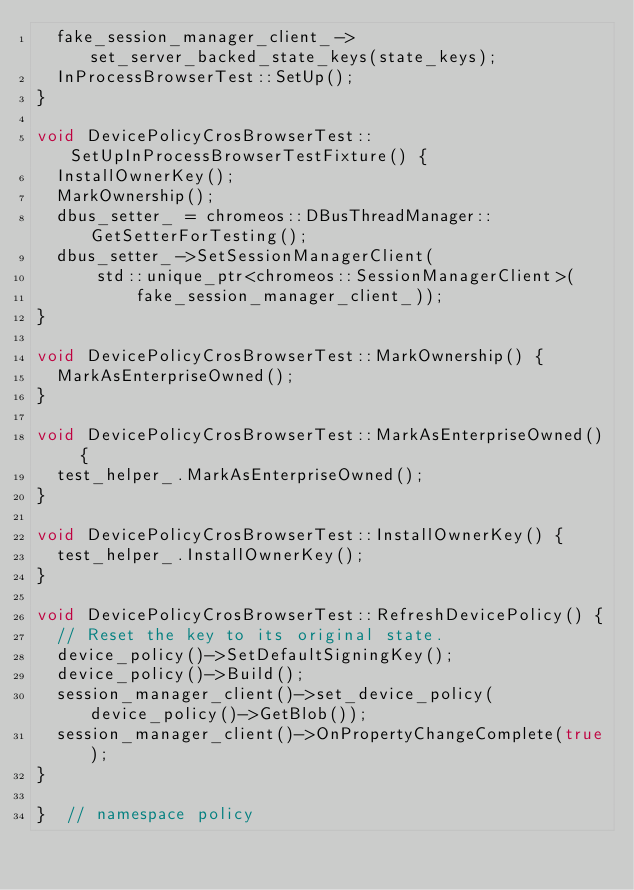<code> <loc_0><loc_0><loc_500><loc_500><_C++_>  fake_session_manager_client_->set_server_backed_state_keys(state_keys);
  InProcessBrowserTest::SetUp();
}

void DevicePolicyCrosBrowserTest::SetUpInProcessBrowserTestFixture() {
  InstallOwnerKey();
  MarkOwnership();
  dbus_setter_ = chromeos::DBusThreadManager::GetSetterForTesting();
  dbus_setter_->SetSessionManagerClient(
      std::unique_ptr<chromeos::SessionManagerClient>(
          fake_session_manager_client_));
}

void DevicePolicyCrosBrowserTest::MarkOwnership() {
  MarkAsEnterpriseOwned();
}

void DevicePolicyCrosBrowserTest::MarkAsEnterpriseOwned() {
  test_helper_.MarkAsEnterpriseOwned();
}

void DevicePolicyCrosBrowserTest::InstallOwnerKey() {
  test_helper_.InstallOwnerKey();
}

void DevicePolicyCrosBrowserTest::RefreshDevicePolicy() {
  // Reset the key to its original state.
  device_policy()->SetDefaultSigningKey();
  device_policy()->Build();
  session_manager_client()->set_device_policy(device_policy()->GetBlob());
  session_manager_client()->OnPropertyChangeComplete(true);
}

}  // namespace policy
</code> 